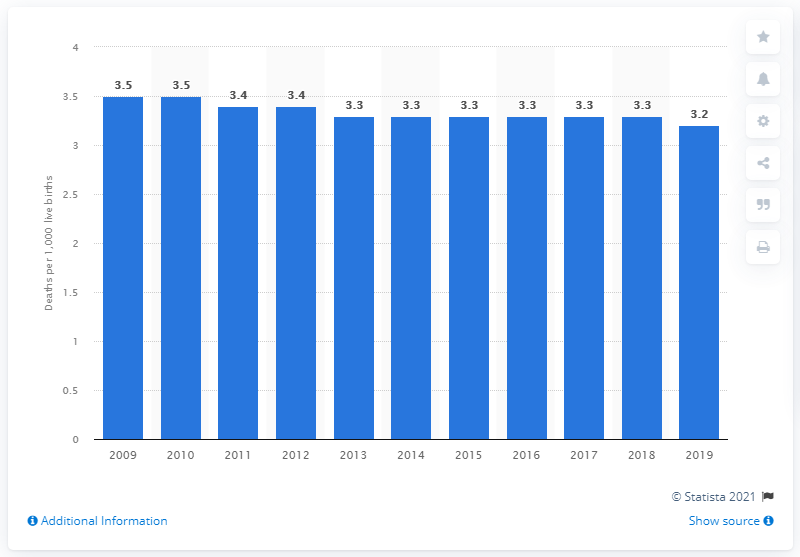Indicate a few pertinent items in this graphic. The infant mortality rate in Germany in 2019 was 3.2 per 1,000 live births. 